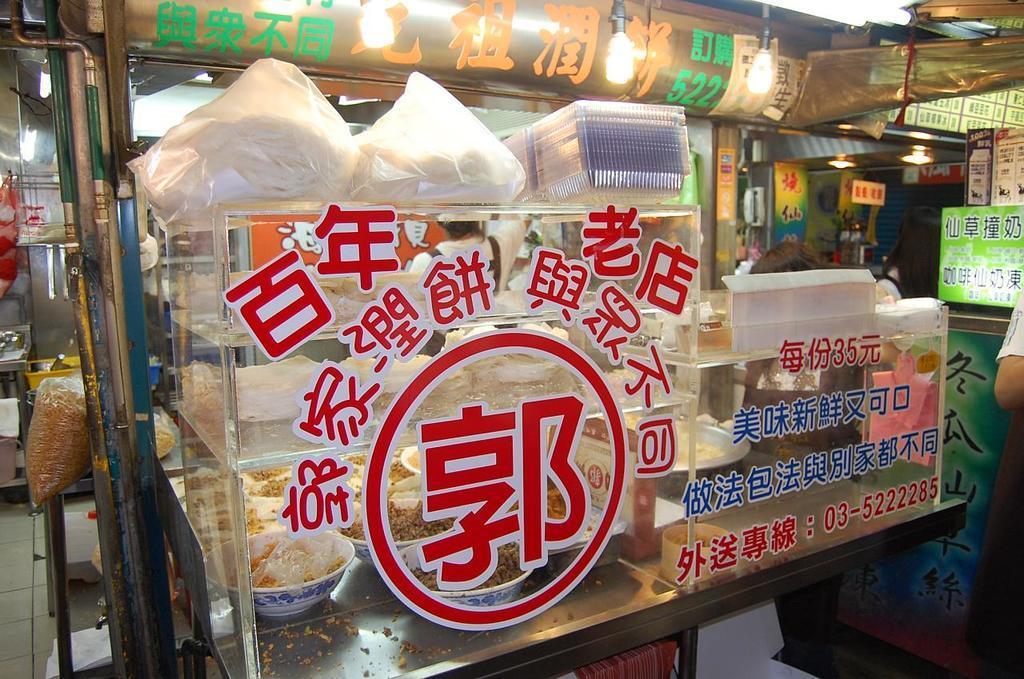How would you summarize this image in a sentence or two? In this image in the center there is one box, and in the box there are some bowls and in the bowels there is some food. And on the box there is some text, and on the box there are some plastic covers and some boxes. And in the background there are some boards, poles, plastic covers, and in the covers there is some food, lights and some other objects. At the bottom there is floor and on the right side of the image there is one person. 